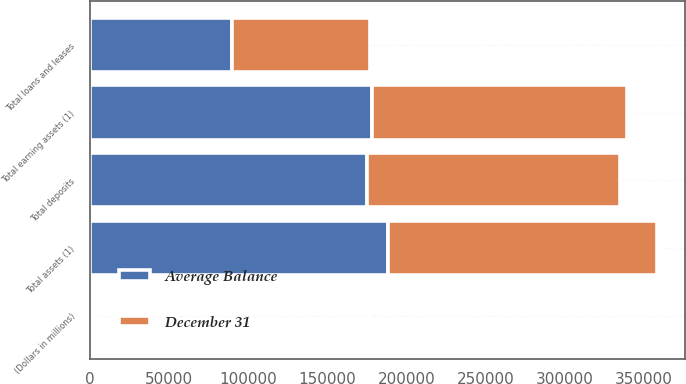<chart> <loc_0><loc_0><loc_500><loc_500><stacked_bar_chart><ecel><fcel>(Dollars in millions)<fcel>Total loans and leases<fcel>Total earning assets (1)<fcel>Total assets (1)<fcel>Total deposits<nl><fcel>Average Balance<fcel>2008<fcel>89400<fcel>178240<fcel>187994<fcel>175107<nl><fcel>December 31<fcel>2008<fcel>87591<fcel>160699<fcel>169986<fcel>159525<nl></chart> 